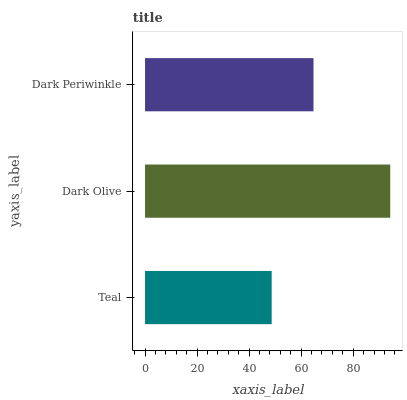Is Teal the minimum?
Answer yes or no. Yes. Is Dark Olive the maximum?
Answer yes or no. Yes. Is Dark Periwinkle the minimum?
Answer yes or no. No. Is Dark Periwinkle the maximum?
Answer yes or no. No. Is Dark Olive greater than Dark Periwinkle?
Answer yes or no. Yes. Is Dark Periwinkle less than Dark Olive?
Answer yes or no. Yes. Is Dark Periwinkle greater than Dark Olive?
Answer yes or no. No. Is Dark Olive less than Dark Periwinkle?
Answer yes or no. No. Is Dark Periwinkle the high median?
Answer yes or no. Yes. Is Dark Periwinkle the low median?
Answer yes or no. Yes. Is Teal the high median?
Answer yes or no. No. Is Dark Olive the low median?
Answer yes or no. No. 